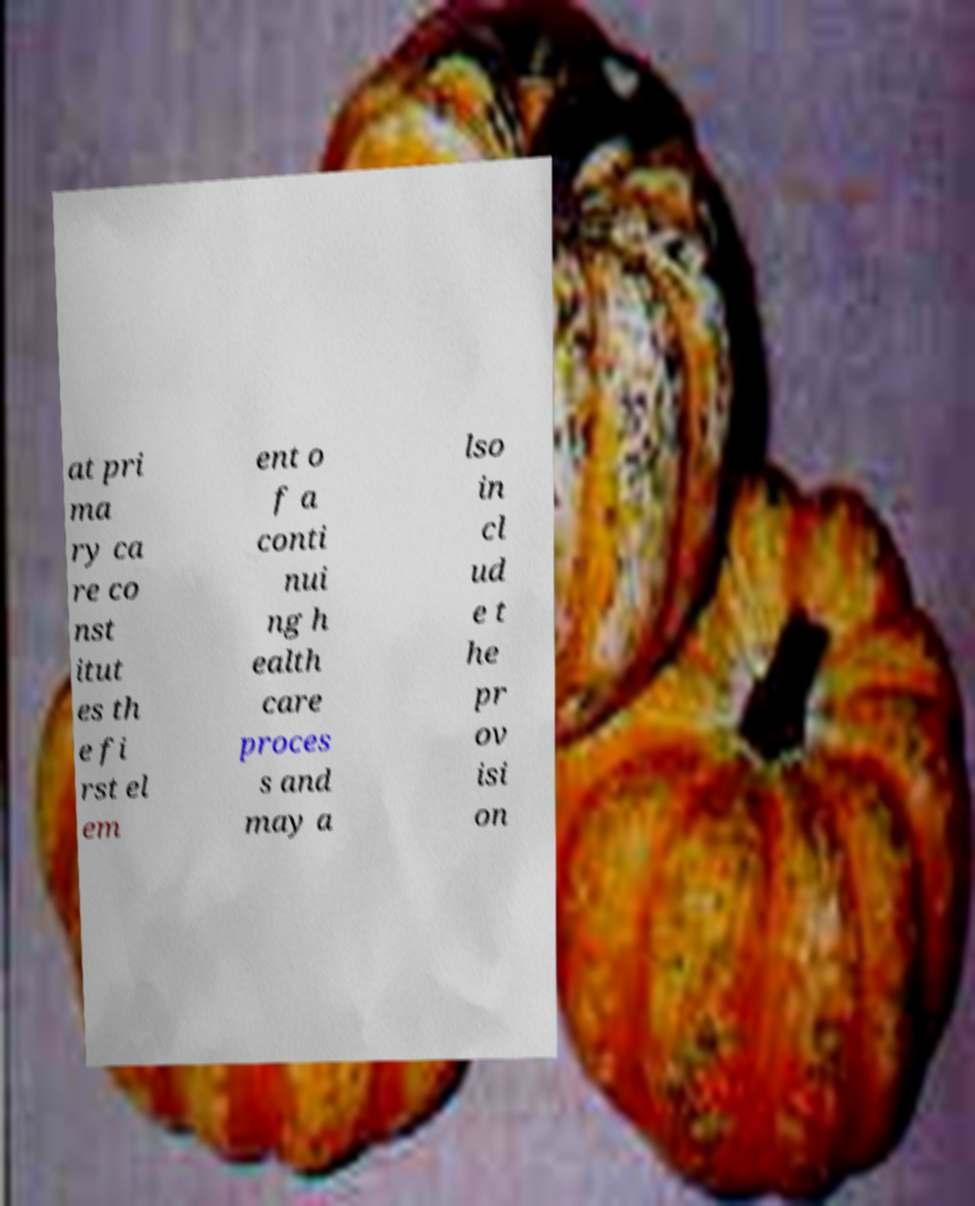Could you extract and type out the text from this image? at pri ma ry ca re co nst itut es th e fi rst el em ent o f a conti nui ng h ealth care proces s and may a lso in cl ud e t he pr ov isi on 